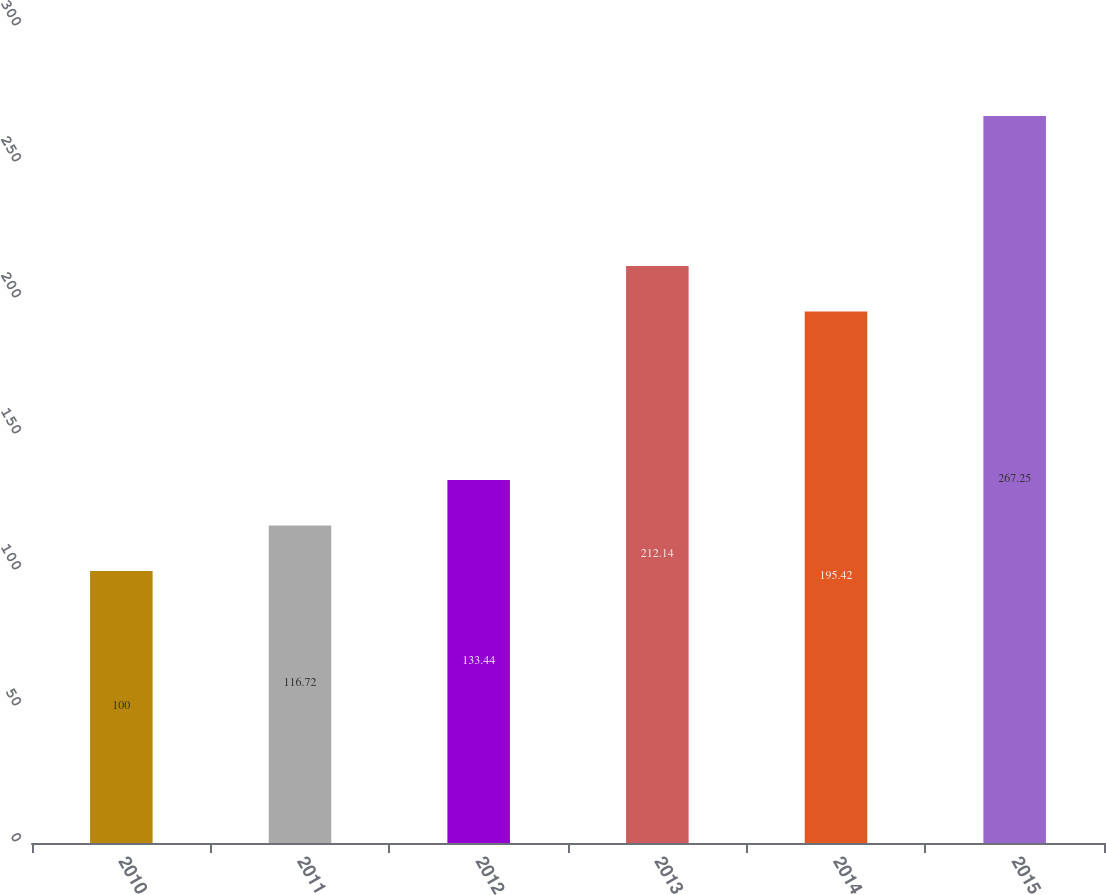<chart> <loc_0><loc_0><loc_500><loc_500><bar_chart><fcel>2010<fcel>2011<fcel>2012<fcel>2013<fcel>2014<fcel>2015<nl><fcel>100<fcel>116.72<fcel>133.44<fcel>212.14<fcel>195.42<fcel>267.25<nl></chart> 